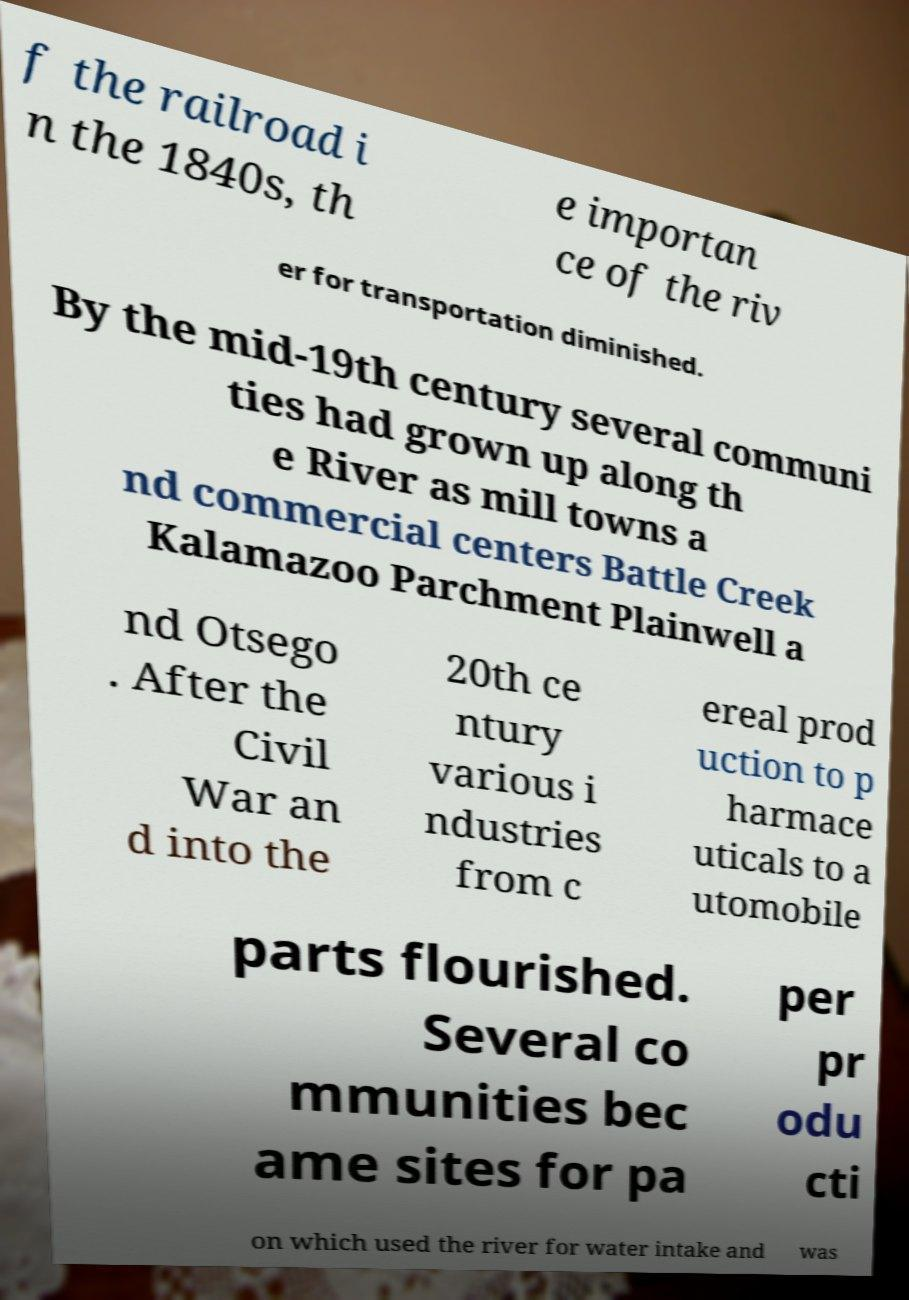Can you accurately transcribe the text from the provided image for me? f the railroad i n the 1840s, th e importan ce of the riv er for transportation diminished. By the mid-19th century several communi ties had grown up along th e River as mill towns a nd commercial centers Battle Creek Kalamazoo Parchment Plainwell a nd Otsego . After the Civil War an d into the 20th ce ntury various i ndustries from c ereal prod uction to p harmace uticals to a utomobile parts flourished. Several co mmunities bec ame sites for pa per pr odu cti on which used the river for water intake and was 